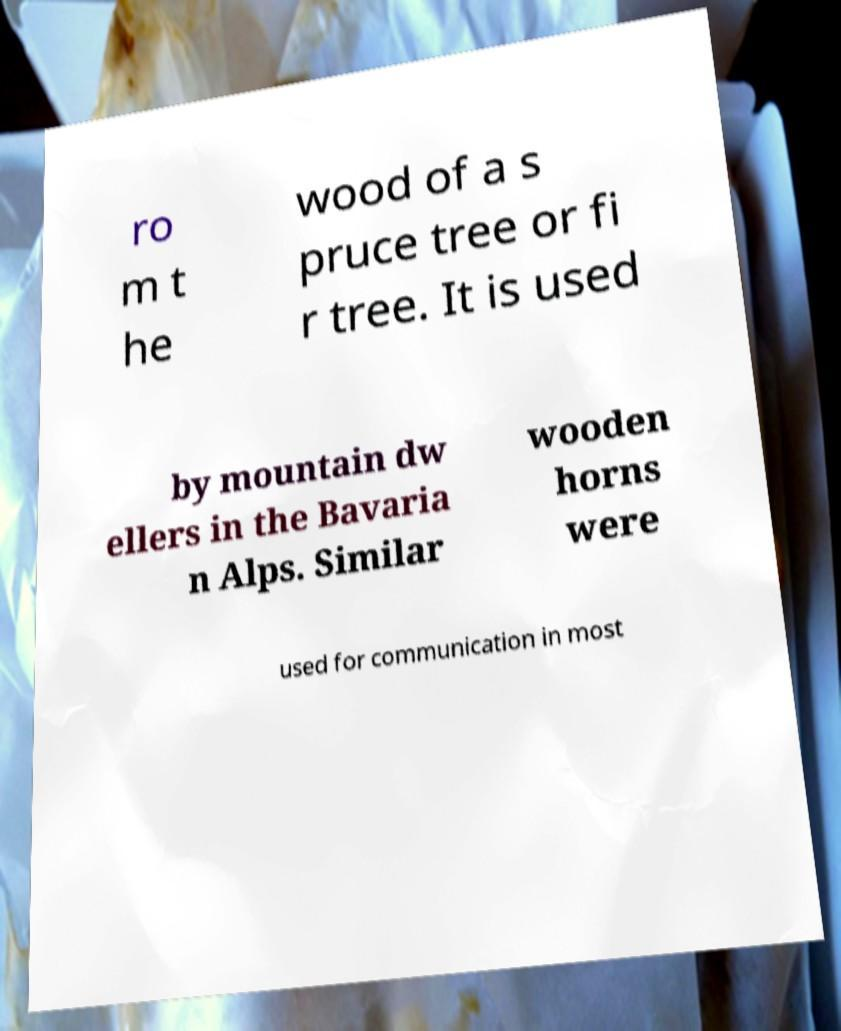Please identify and transcribe the text found in this image. ro m t he wood of a s pruce tree or fi r tree. It is used by mountain dw ellers in the Bavaria n Alps. Similar wooden horns were used for communication in most 